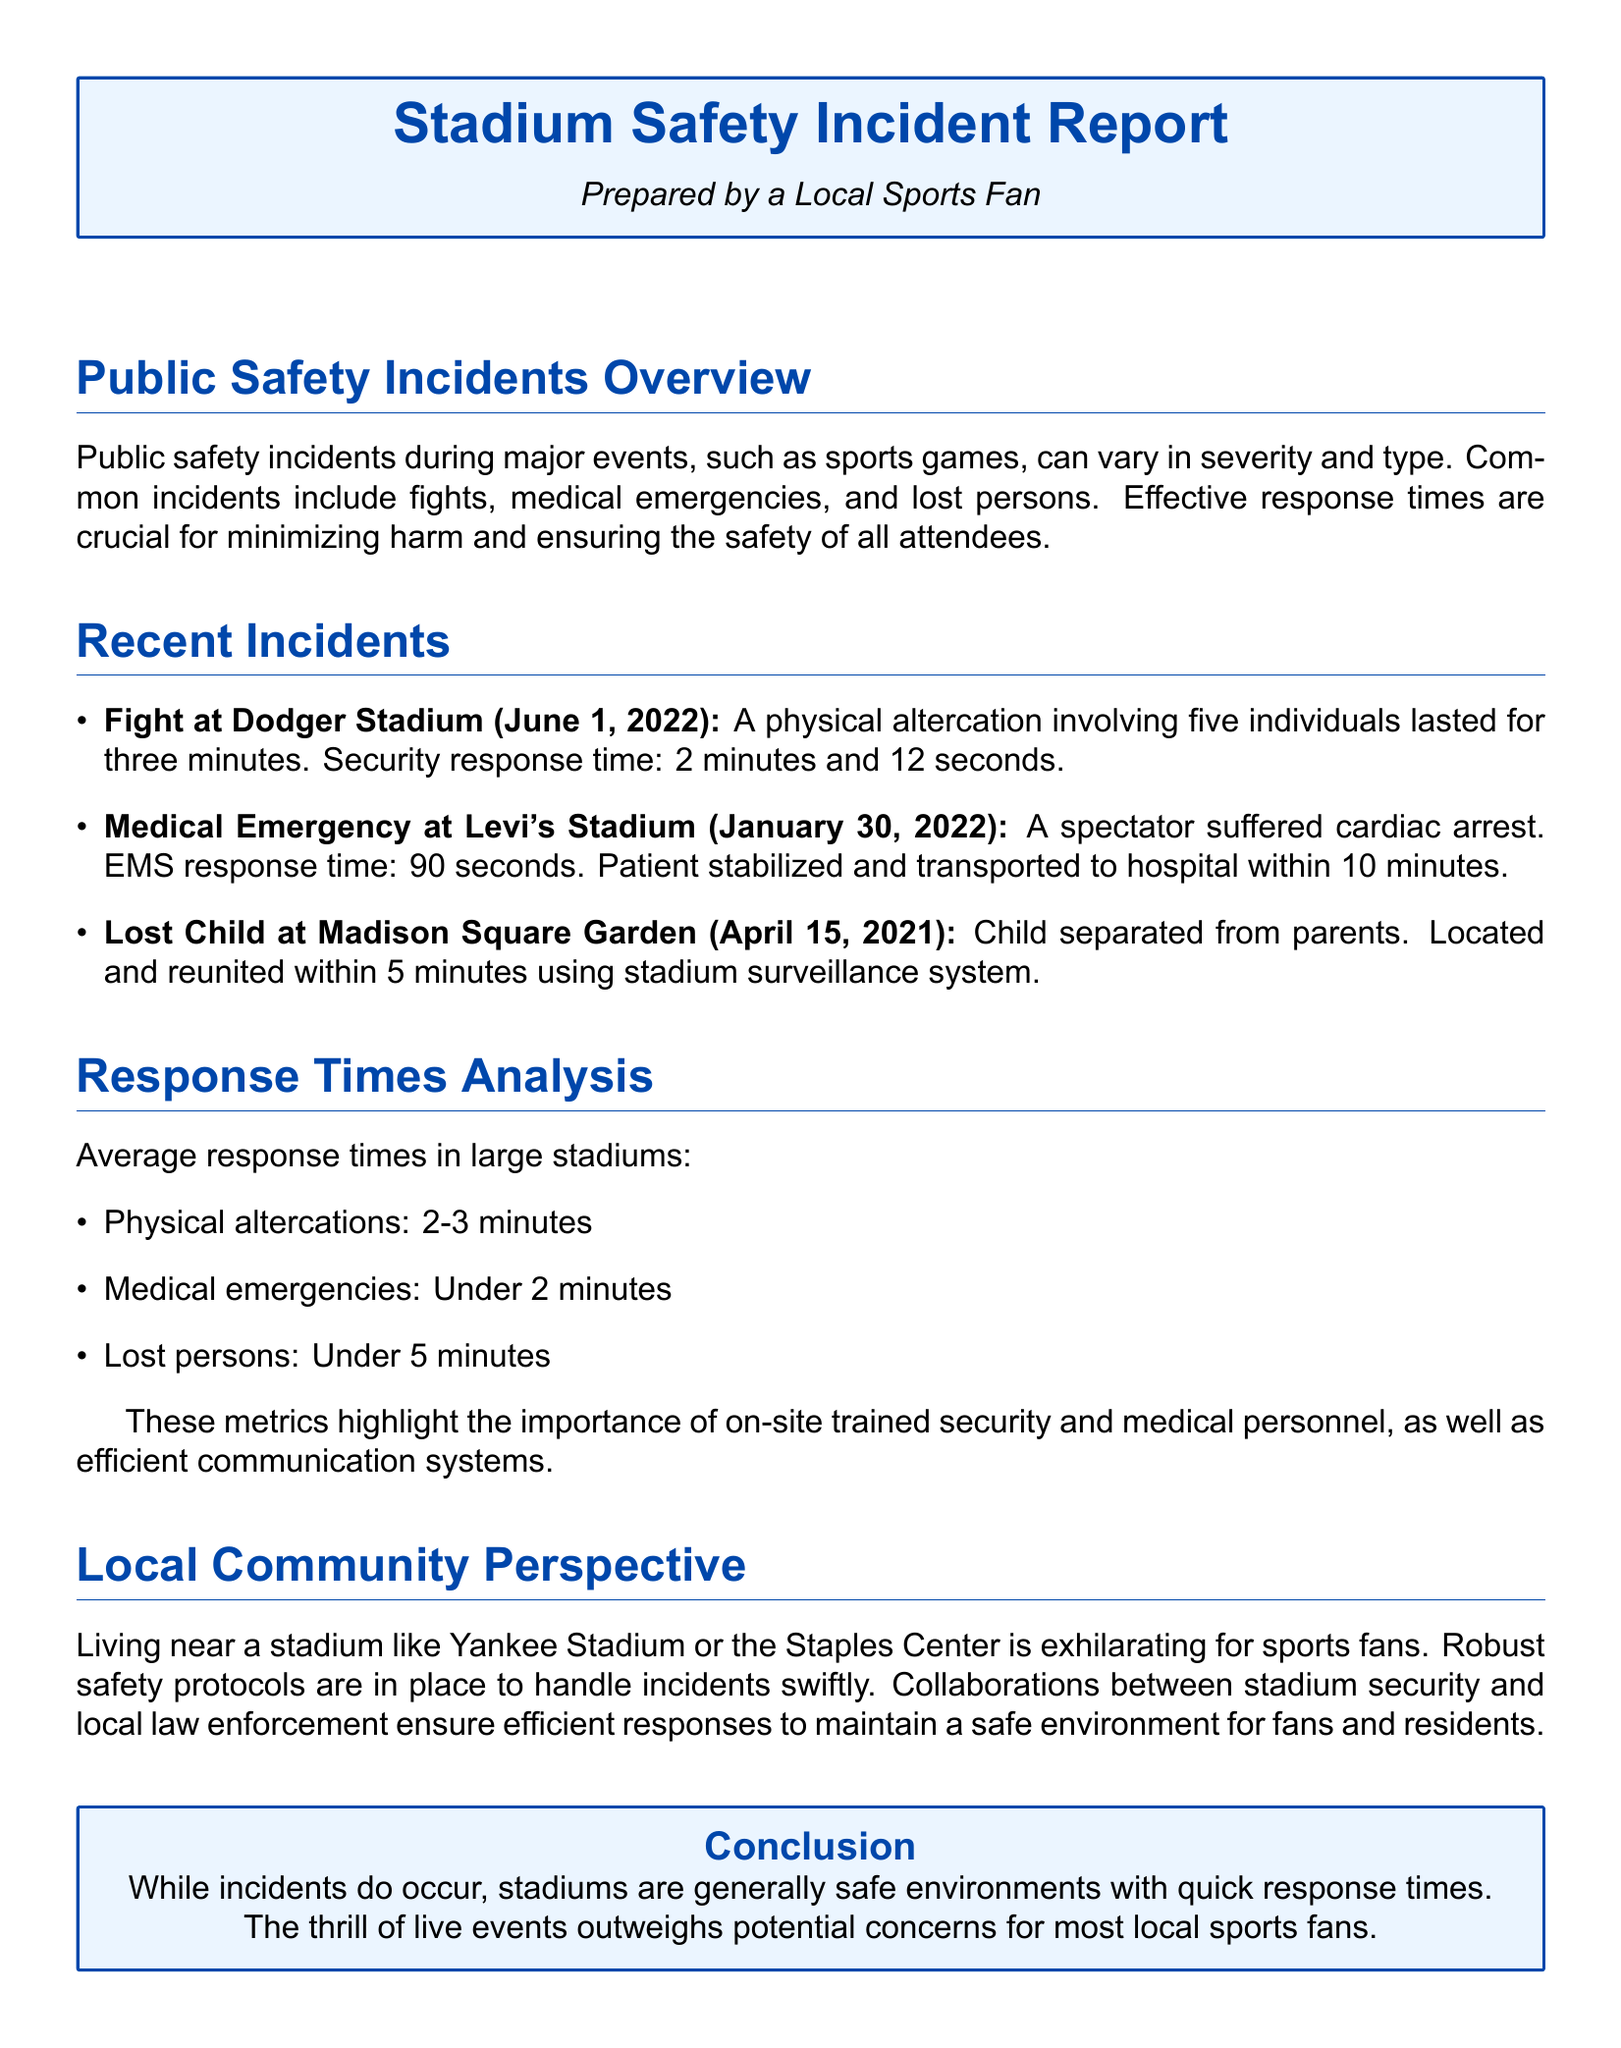What was the incident type at Dodger Stadium? The incident type was a physical altercation involving five individuals.
Answer: Fight What was the security response time for the fight? The security response time mentioned in the document is 2 minutes and 12 seconds.
Answer: 2 minutes and 12 seconds How long did the medical emergency response take at Levi's Stadium? The EMS response time for the medical emergency was 90 seconds.
Answer: 90 seconds What was the average response time for lost persons? The document specifies that the average response time for lost persons is under 5 minutes.
Answer: Under 5 minutes How long did it take to reunite the lost child with their parents? The lost child was located and reunited within 5 minutes.
Answer: 5 minutes What type of incidents are common during events? The common incidents include fights, medical emergencies, and lost persons.
Answer: Fights, medical emergencies, lost persons What is the average response time for medical emergencies? The average response time for medical emergencies is stated as under 2 minutes.
Answer: Under 2 minutes Who ensures efficient responses in stadiums? Collaborations between stadium security and local law enforcement ensure efficient responses.
Answer: Stadium security and local law enforcement What type of document is this? The document is an incident report focused on public safety incidents during events.
Answer: Incident report 